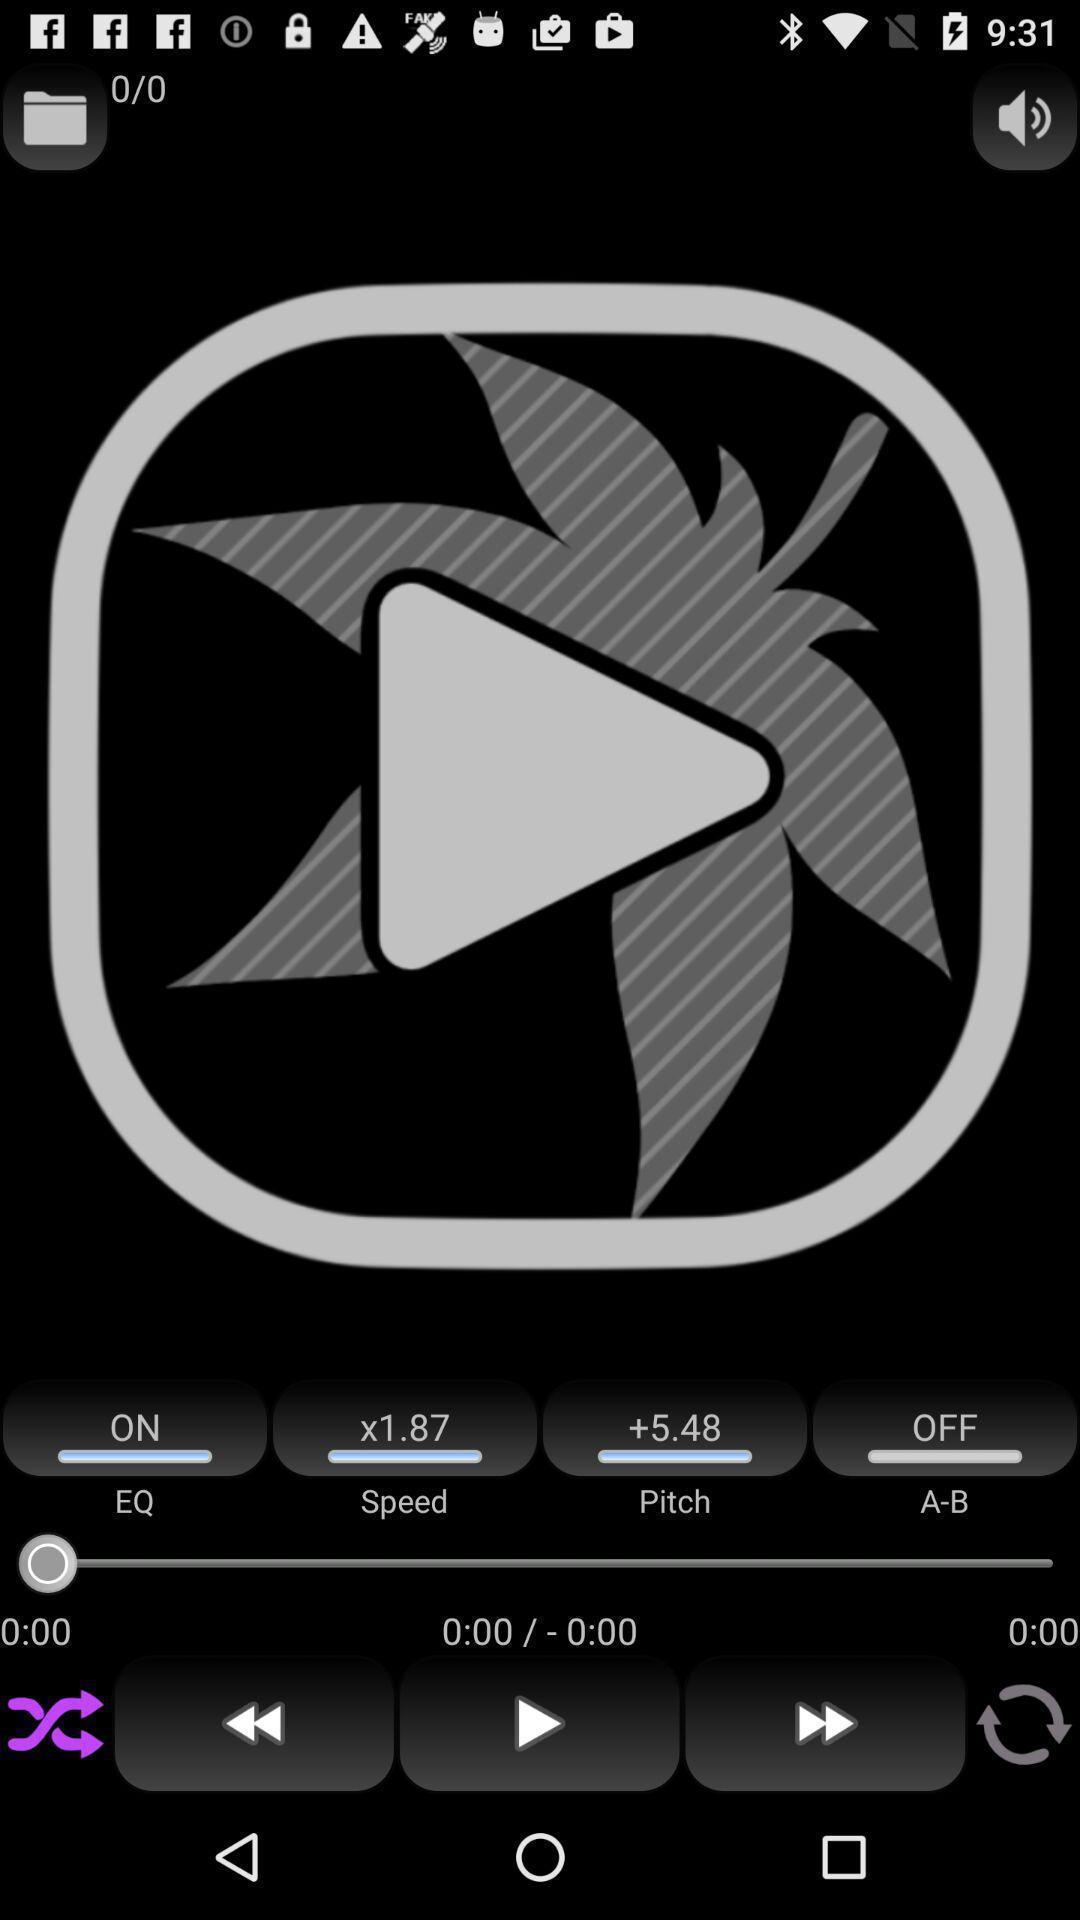Provide a description of this screenshot. Screen showing various options of a music player app. 